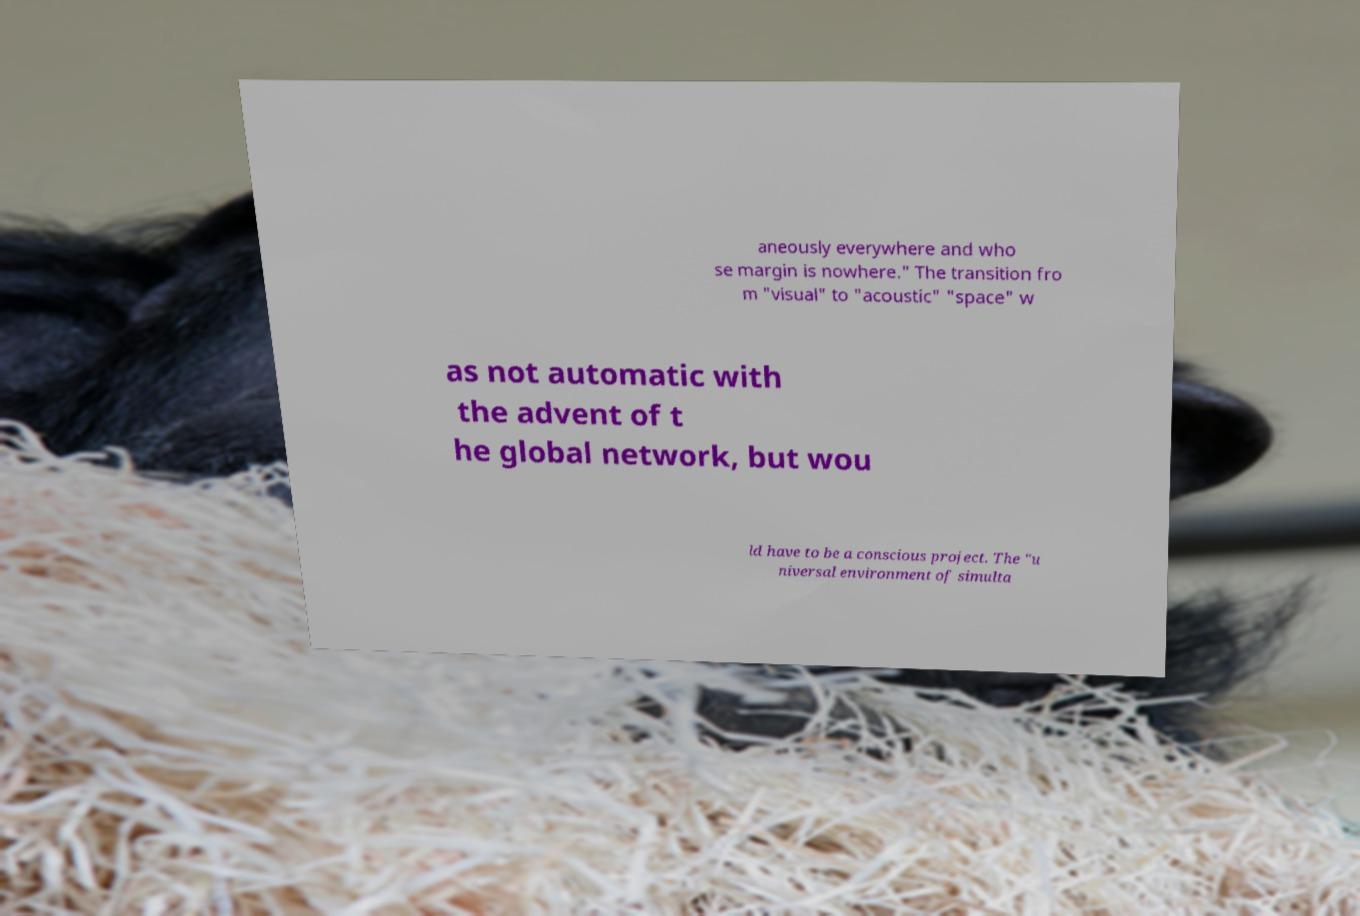Please read and relay the text visible in this image. What does it say? aneously everywhere and who se margin is nowhere." The transition fro m "visual" to "acoustic" "space" w as not automatic with the advent of t he global network, but wou ld have to be a conscious project. The "u niversal environment of simulta 